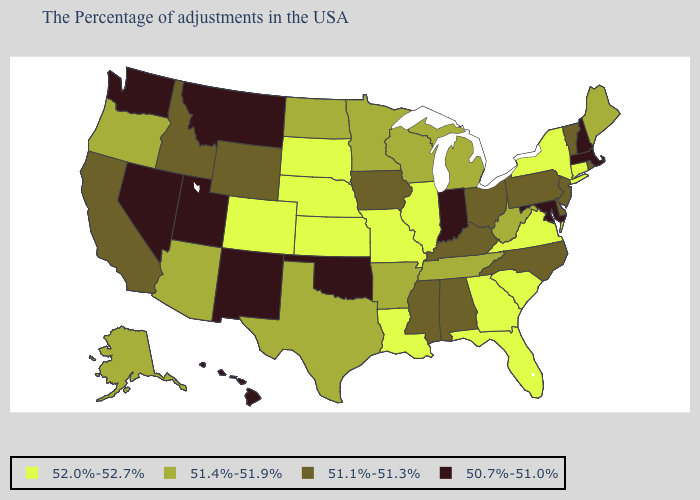Name the states that have a value in the range 51.4%-51.9%?
Answer briefly. Maine, West Virginia, Michigan, Tennessee, Wisconsin, Arkansas, Minnesota, Texas, North Dakota, Arizona, Oregon, Alaska. What is the value of Arkansas?
Short answer required. 51.4%-51.9%. What is the value of Connecticut?
Be succinct. 52.0%-52.7%. What is the value of Massachusetts?
Short answer required. 50.7%-51.0%. Does Oklahoma have the lowest value in the South?
Short answer required. Yes. How many symbols are there in the legend?
Quick response, please. 4. Name the states that have a value in the range 51.4%-51.9%?
Be succinct. Maine, West Virginia, Michigan, Tennessee, Wisconsin, Arkansas, Minnesota, Texas, North Dakota, Arizona, Oregon, Alaska. What is the lowest value in the South?
Answer briefly. 50.7%-51.0%. Name the states that have a value in the range 50.7%-51.0%?
Quick response, please. Massachusetts, New Hampshire, Maryland, Indiana, Oklahoma, New Mexico, Utah, Montana, Nevada, Washington, Hawaii. What is the value of Vermont?
Concise answer only. 51.1%-51.3%. Which states hav the highest value in the West?
Write a very short answer. Colorado. What is the value of Minnesota?
Concise answer only. 51.4%-51.9%. Which states hav the highest value in the MidWest?
Write a very short answer. Illinois, Missouri, Kansas, Nebraska, South Dakota. Name the states that have a value in the range 51.1%-51.3%?
Be succinct. Rhode Island, Vermont, New Jersey, Delaware, Pennsylvania, North Carolina, Ohio, Kentucky, Alabama, Mississippi, Iowa, Wyoming, Idaho, California. 